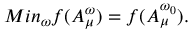<formula> <loc_0><loc_0><loc_500><loc_500>M i n _ { \omega } f ( A _ { \mu } ^ { \omega } ) = f ( A _ { \mu } ^ { \omega _ { 0 } } ) .</formula> 